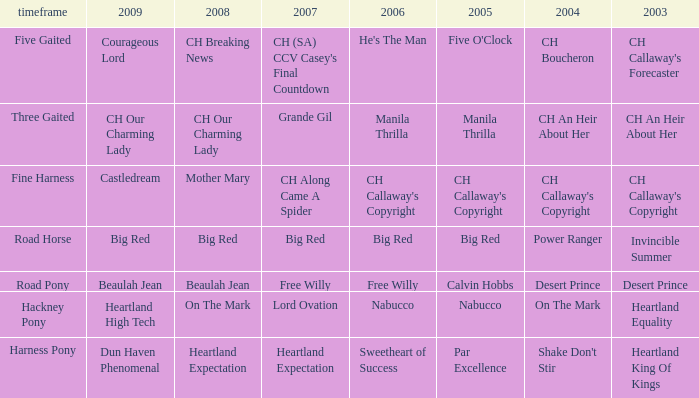What is the 2008 for 2009 heartland high tech? On The Mark. 